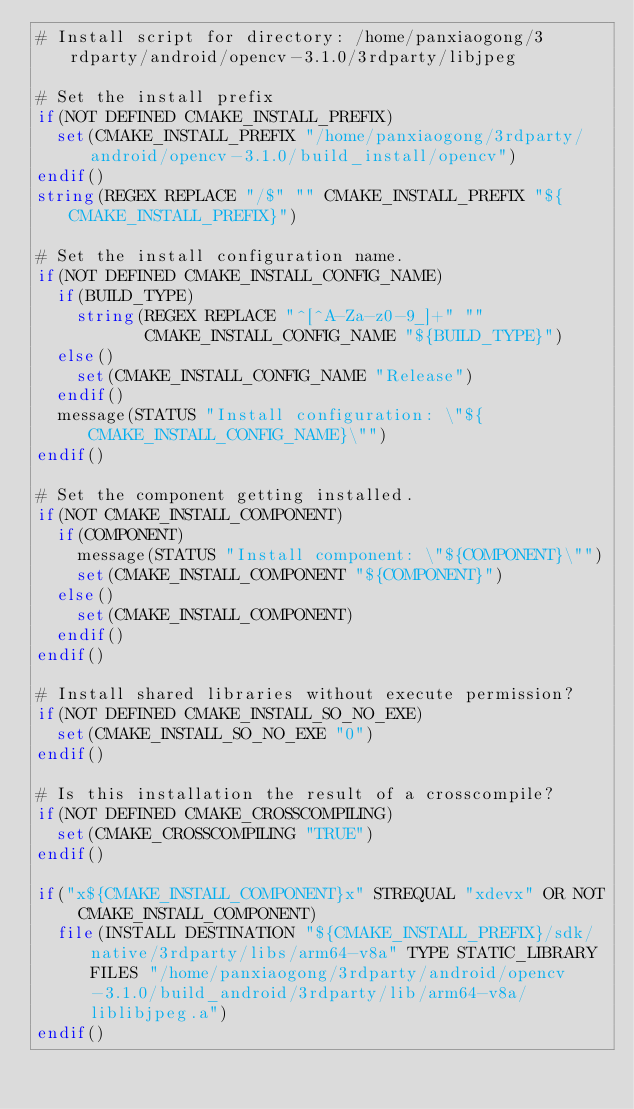Convert code to text. <code><loc_0><loc_0><loc_500><loc_500><_CMake_># Install script for directory: /home/panxiaogong/3rdparty/android/opencv-3.1.0/3rdparty/libjpeg

# Set the install prefix
if(NOT DEFINED CMAKE_INSTALL_PREFIX)
  set(CMAKE_INSTALL_PREFIX "/home/panxiaogong/3rdparty/android/opencv-3.1.0/build_install/opencv")
endif()
string(REGEX REPLACE "/$" "" CMAKE_INSTALL_PREFIX "${CMAKE_INSTALL_PREFIX}")

# Set the install configuration name.
if(NOT DEFINED CMAKE_INSTALL_CONFIG_NAME)
  if(BUILD_TYPE)
    string(REGEX REPLACE "^[^A-Za-z0-9_]+" ""
           CMAKE_INSTALL_CONFIG_NAME "${BUILD_TYPE}")
  else()
    set(CMAKE_INSTALL_CONFIG_NAME "Release")
  endif()
  message(STATUS "Install configuration: \"${CMAKE_INSTALL_CONFIG_NAME}\"")
endif()

# Set the component getting installed.
if(NOT CMAKE_INSTALL_COMPONENT)
  if(COMPONENT)
    message(STATUS "Install component: \"${COMPONENT}\"")
    set(CMAKE_INSTALL_COMPONENT "${COMPONENT}")
  else()
    set(CMAKE_INSTALL_COMPONENT)
  endif()
endif()

# Install shared libraries without execute permission?
if(NOT DEFINED CMAKE_INSTALL_SO_NO_EXE)
  set(CMAKE_INSTALL_SO_NO_EXE "0")
endif()

# Is this installation the result of a crosscompile?
if(NOT DEFINED CMAKE_CROSSCOMPILING)
  set(CMAKE_CROSSCOMPILING "TRUE")
endif()

if("x${CMAKE_INSTALL_COMPONENT}x" STREQUAL "xdevx" OR NOT CMAKE_INSTALL_COMPONENT)
  file(INSTALL DESTINATION "${CMAKE_INSTALL_PREFIX}/sdk/native/3rdparty/libs/arm64-v8a" TYPE STATIC_LIBRARY FILES "/home/panxiaogong/3rdparty/android/opencv-3.1.0/build_android/3rdparty/lib/arm64-v8a/liblibjpeg.a")
endif()

</code> 